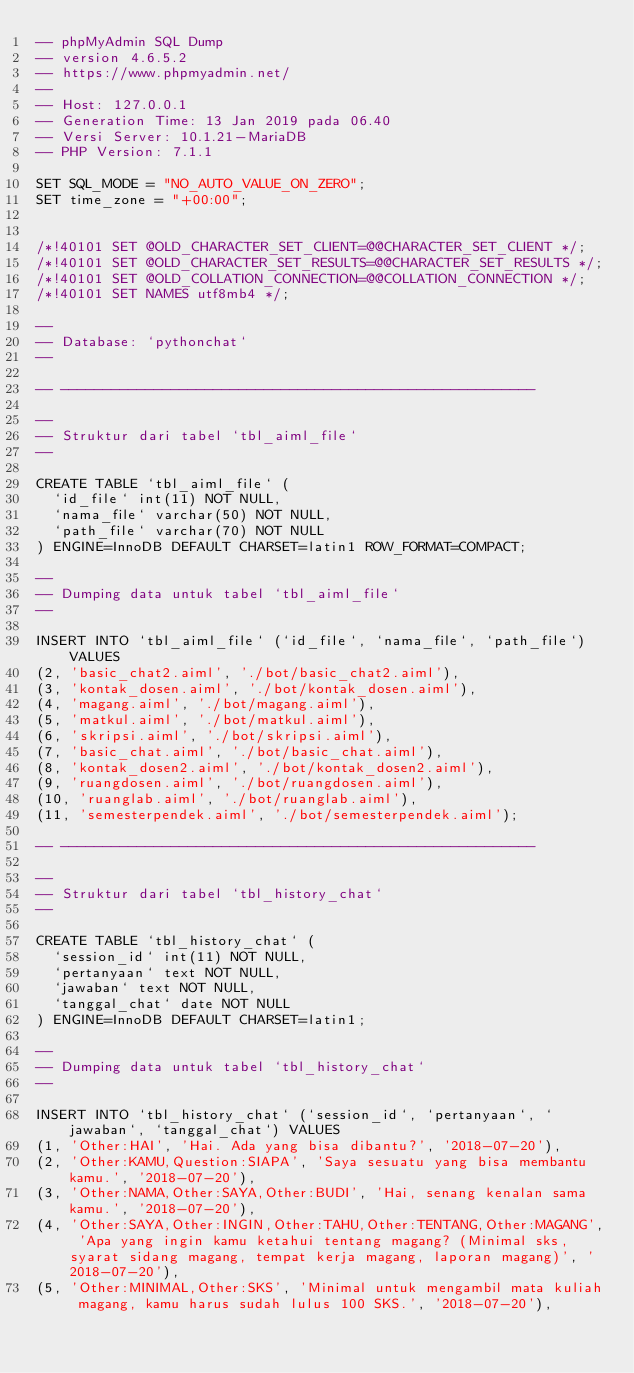Convert code to text. <code><loc_0><loc_0><loc_500><loc_500><_SQL_>-- phpMyAdmin SQL Dump
-- version 4.6.5.2
-- https://www.phpmyadmin.net/
--
-- Host: 127.0.0.1
-- Generation Time: 13 Jan 2019 pada 06.40
-- Versi Server: 10.1.21-MariaDB
-- PHP Version: 7.1.1

SET SQL_MODE = "NO_AUTO_VALUE_ON_ZERO";
SET time_zone = "+00:00";


/*!40101 SET @OLD_CHARACTER_SET_CLIENT=@@CHARACTER_SET_CLIENT */;
/*!40101 SET @OLD_CHARACTER_SET_RESULTS=@@CHARACTER_SET_RESULTS */;
/*!40101 SET @OLD_COLLATION_CONNECTION=@@COLLATION_CONNECTION */;
/*!40101 SET NAMES utf8mb4 */;

--
-- Database: `pythonchat`
--

-- --------------------------------------------------------

--
-- Struktur dari tabel `tbl_aiml_file`
--

CREATE TABLE `tbl_aiml_file` (
  `id_file` int(11) NOT NULL,
  `nama_file` varchar(50) NOT NULL,
  `path_file` varchar(70) NOT NULL
) ENGINE=InnoDB DEFAULT CHARSET=latin1 ROW_FORMAT=COMPACT;

--
-- Dumping data untuk tabel `tbl_aiml_file`
--

INSERT INTO `tbl_aiml_file` (`id_file`, `nama_file`, `path_file`) VALUES
(2, 'basic_chat2.aiml', './bot/basic_chat2.aiml'),
(3, 'kontak_dosen.aiml', './bot/kontak_dosen.aiml'),
(4, 'magang.aiml', './bot/magang.aiml'),
(5, 'matkul.aiml', './bot/matkul.aiml'),
(6, 'skripsi.aiml', './bot/skripsi.aiml'),
(7, 'basic_chat.aiml', './bot/basic_chat.aiml'),
(8, 'kontak_dosen2.aiml', './bot/kontak_dosen2.aiml'),
(9, 'ruangdosen.aiml', './bot/ruangdosen.aiml'),
(10, 'ruanglab.aiml', './bot/ruanglab.aiml'),
(11, 'semesterpendek.aiml', './bot/semesterpendek.aiml');

-- --------------------------------------------------------

--
-- Struktur dari tabel `tbl_history_chat`
--

CREATE TABLE `tbl_history_chat` (
  `session_id` int(11) NOT NULL,
  `pertanyaan` text NOT NULL,
  `jawaban` text NOT NULL,
  `tanggal_chat` date NOT NULL
) ENGINE=InnoDB DEFAULT CHARSET=latin1;

--
-- Dumping data untuk tabel `tbl_history_chat`
--

INSERT INTO `tbl_history_chat` (`session_id`, `pertanyaan`, `jawaban`, `tanggal_chat`) VALUES
(1, 'Other:HAI', 'Hai. Ada yang bisa dibantu?', '2018-07-20'),
(2, 'Other:KAMU,Question:SIAPA', 'Saya sesuatu yang bisa membantu kamu.', '2018-07-20'),
(3, 'Other:NAMA,Other:SAYA,Other:BUDI', 'Hai, senang kenalan sama kamu.', '2018-07-20'),
(4, 'Other:SAYA,Other:INGIN,Other:TAHU,Other:TENTANG,Other:MAGANG', 'Apa yang ingin kamu ketahui tentang magang? (Minimal sks, syarat sidang magang, tempat kerja magang, laporan magang)', '2018-07-20'),
(5, 'Other:MINIMAL,Other:SKS', 'Minimal untuk mengambil mata kuliah magang, kamu harus sudah lulus 100 SKS.', '2018-07-20'),</code> 